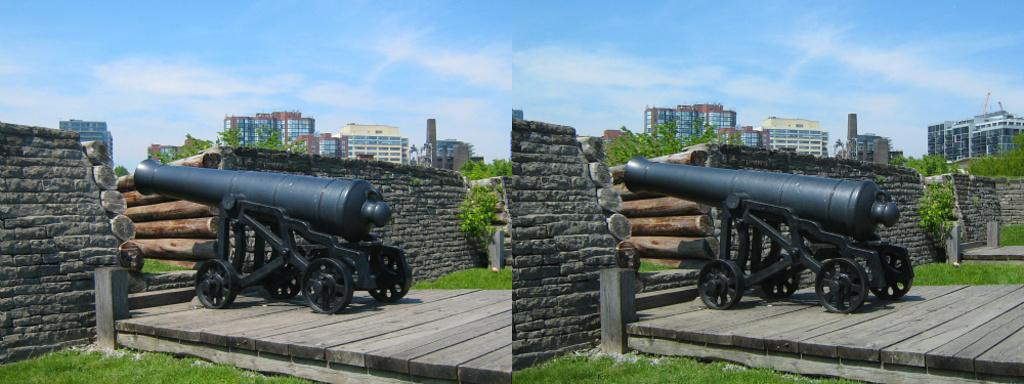What type of artwork is depicted in the image? The image contains a collage of various elements. What specific object can be seen in the collage? A rifle is present in the collage. What material is featured in the collage? Wood is present in the collage. What type of structures are included in the collage? Buildings are present in the collage. What architectural feature is visible in the collage? A wall is present in the collage. What type of natural elements are included in the collage? Trees are present in the collage. What part of the natural environment is visible in the collage? The sky is present in the collage. What type of drawer can be seen in the collage? There is no drawer present in the collage; it features a collage of various elements including a rifle, wood, buildings, a wall, trees, and the sky. What street is visible in the collage? There is no street present in the collage; it features a collage of various elements including a rifle, wood, buildings, a wall, trees, and the sky. 